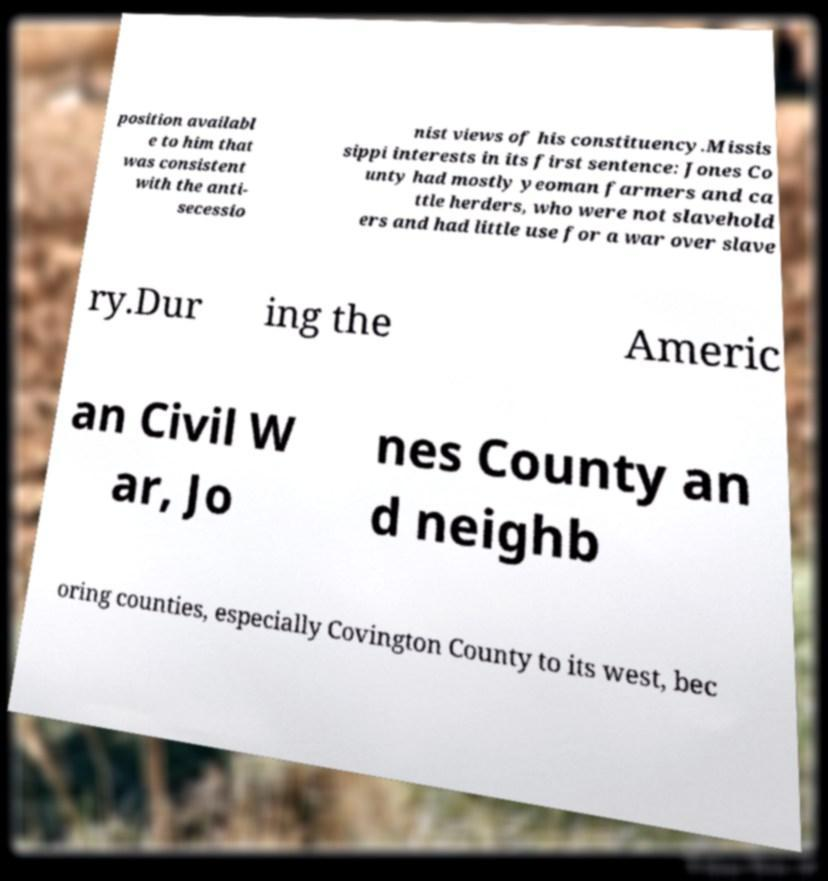Could you assist in decoding the text presented in this image and type it out clearly? position availabl e to him that was consistent with the anti- secessio nist views of his constituency.Missis sippi interests in its first sentence: Jones Co unty had mostly yeoman farmers and ca ttle herders, who were not slavehold ers and had little use for a war over slave ry.Dur ing the Americ an Civil W ar, Jo nes County an d neighb oring counties, especially Covington County to its west, bec 